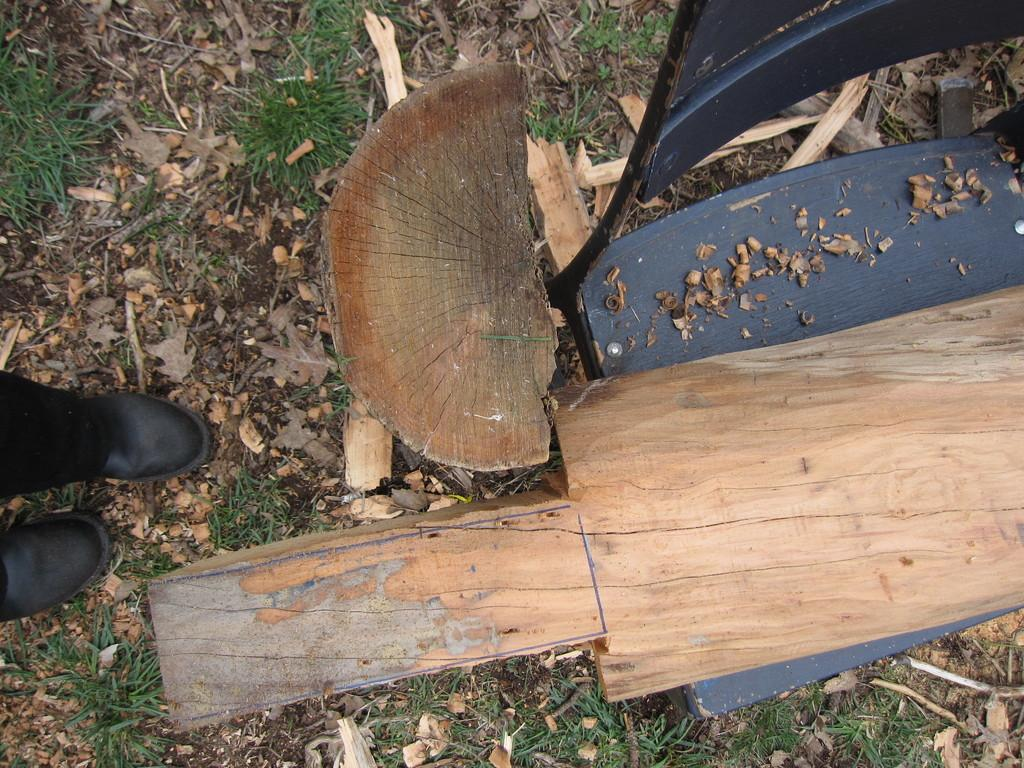What object is located on the right side of the image? There is a chair on the right side of the image. What is placed on the chair? There is a log on the chair. Are there any other logs visible in the image? Yes, there is another log beside the chair. Can you describe the person in the image? There is a person on the left side of the image, but only their boots are visible. What type of whip is the person using to move the logs in the image? There is no whip present in the image, and the person is not using any tool to move the logs. 